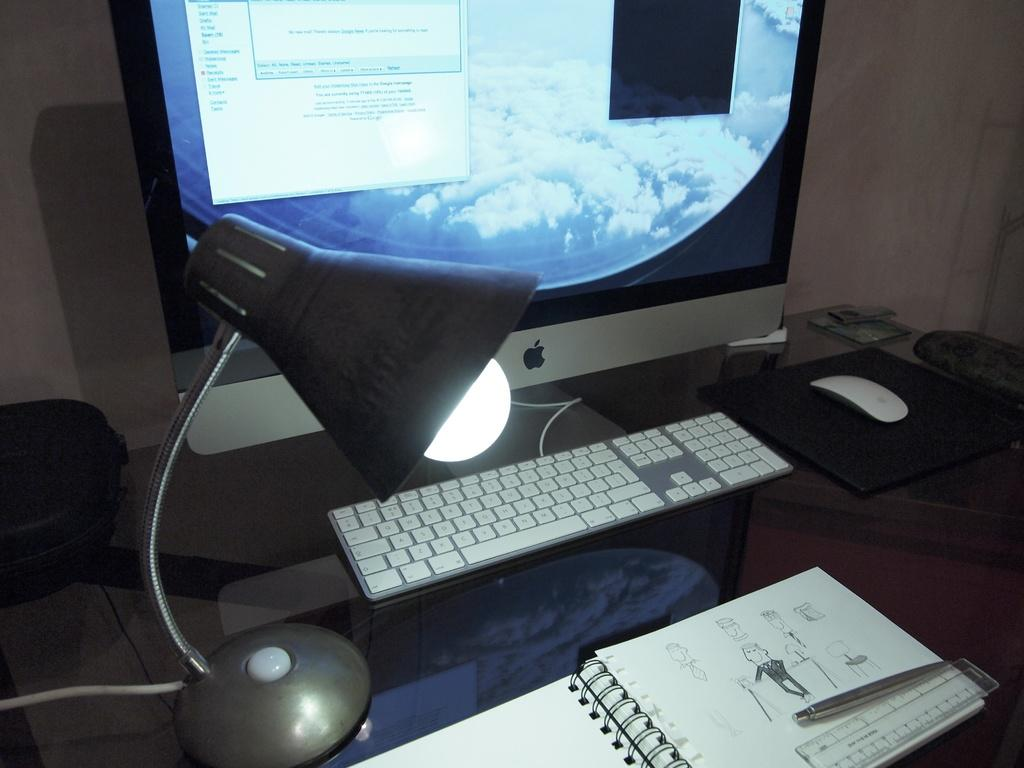<image>
Create a compact narrative representing the image presented. A window on the computer monitor reads, "No new mail." 